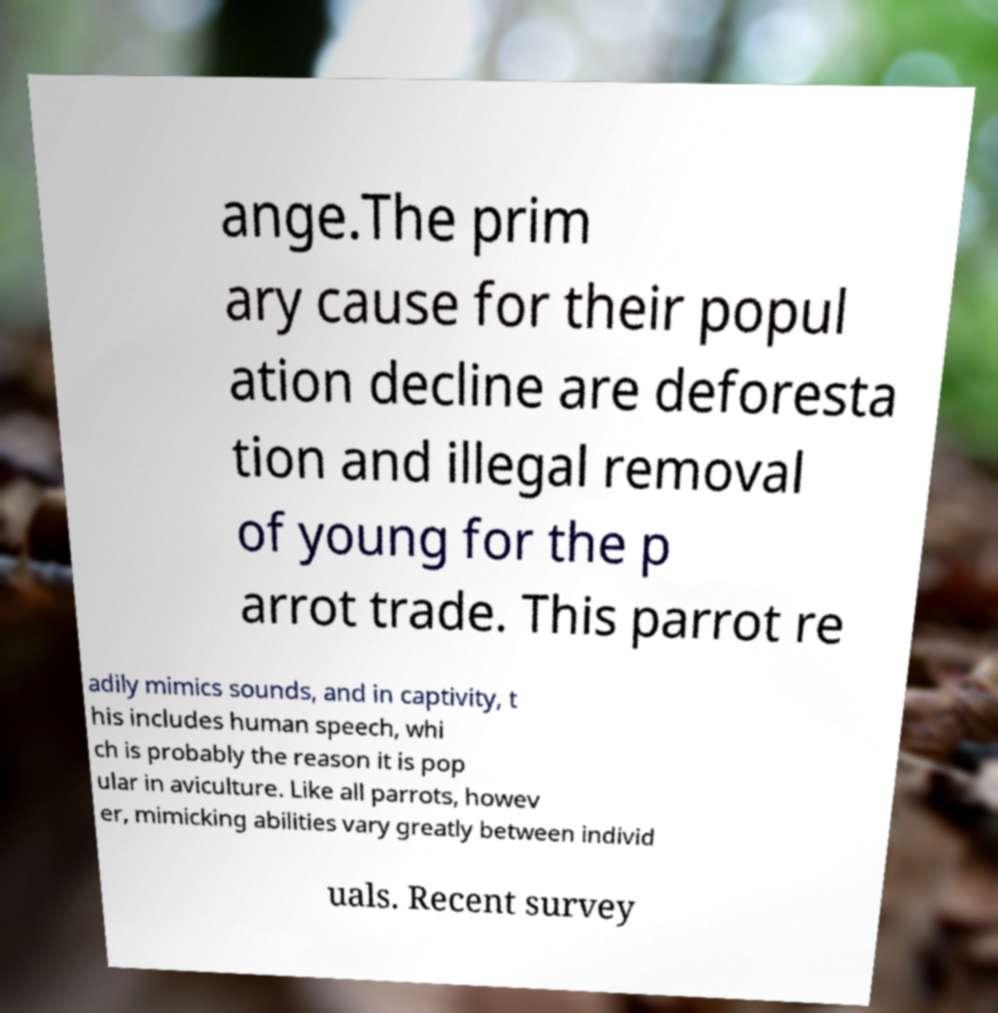Please read and relay the text visible in this image. What does it say? ange.The prim ary cause for their popul ation decline are deforesta tion and illegal removal of young for the p arrot trade. This parrot re adily mimics sounds, and in captivity, t his includes human speech, whi ch is probably the reason it is pop ular in aviculture. Like all parrots, howev er, mimicking abilities vary greatly between individ uals. Recent survey 